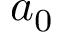<formula> <loc_0><loc_0><loc_500><loc_500>a _ { 0 }</formula> 